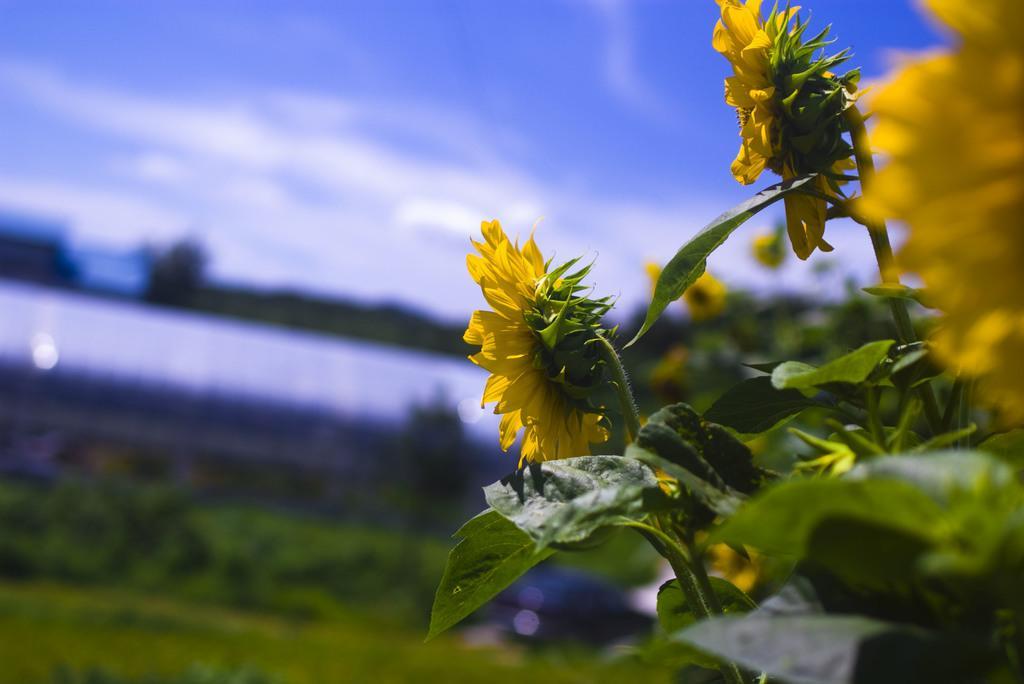How would you summarize this image in a sentence or two? On the right side of the picture we can see sunflower plants. In this picture can see flowers, stems and leaves. Background portion of the picture is blurred and the sky is visible. 